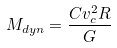Convert formula to latex. <formula><loc_0><loc_0><loc_500><loc_500>M _ { d y n } = \frac { C v _ { c } ^ { 2 } R } { G }</formula> 